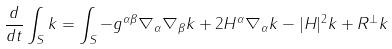<formula> <loc_0><loc_0><loc_500><loc_500>\frac { d } { d t } \int _ { S } k = \int _ { S } - g ^ { \alpha \beta } \nabla _ { \alpha } \nabla _ { \beta } k + 2 H ^ { \alpha } \nabla _ { \alpha } k - | H | ^ { 2 } k + R ^ { \bot } k</formula> 